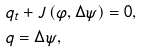<formula> <loc_0><loc_0><loc_500><loc_500>& q _ { t } + J \left ( \varphi , \Delta \psi \right ) = 0 , \\ & q = \Delta \psi ,</formula> 